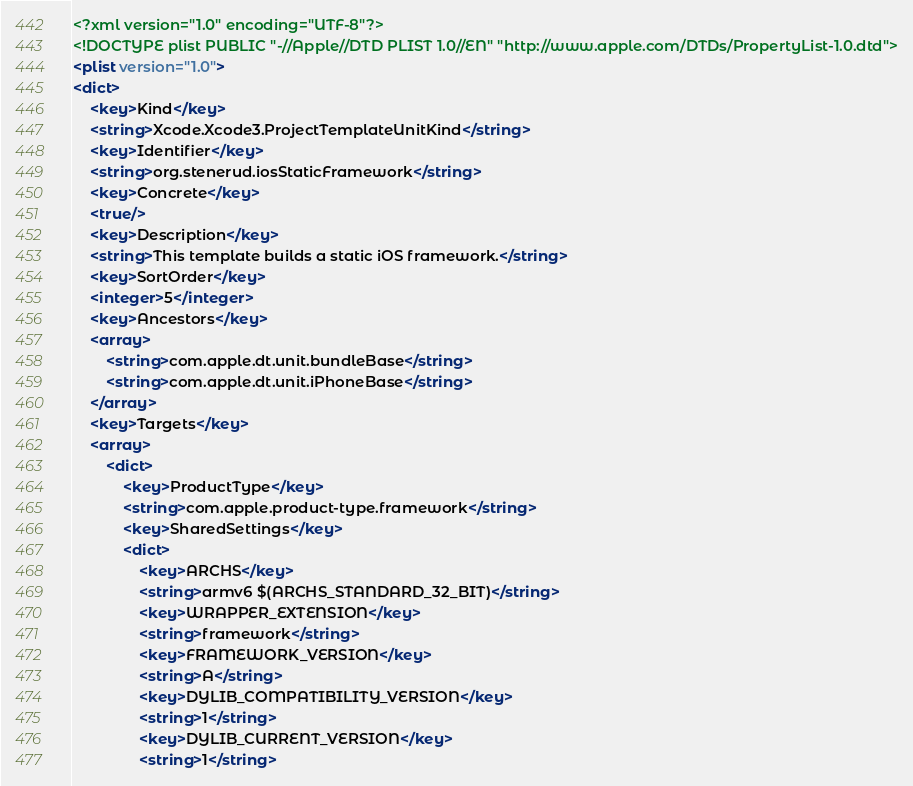<code> <loc_0><loc_0><loc_500><loc_500><_XML_><?xml version="1.0" encoding="UTF-8"?>
<!DOCTYPE plist PUBLIC "-//Apple//DTD PLIST 1.0//EN" "http://www.apple.com/DTDs/PropertyList-1.0.dtd">
<plist version="1.0">
<dict>
	<key>Kind</key>
	<string>Xcode.Xcode3.ProjectTemplateUnitKind</string>
	<key>Identifier</key>
	<string>org.stenerud.iosStaticFramework</string>
	<key>Concrete</key>
	<true/>
	<key>Description</key>
	<string>This template builds a static iOS framework.</string>
	<key>SortOrder</key>
	<integer>5</integer>
	<key>Ancestors</key>
	<array>
		<string>com.apple.dt.unit.bundleBase</string>
		<string>com.apple.dt.unit.iPhoneBase</string>
	</array>
	<key>Targets</key>
	<array>
		<dict>
			<key>ProductType</key>
			<string>com.apple.product-type.framework</string>
			<key>SharedSettings</key>
			<dict>
				<key>ARCHS</key>
				<string>armv6 $(ARCHS_STANDARD_32_BIT)</string>
				<key>WRAPPER_EXTENSION</key>
				<string>framework</string>
				<key>FRAMEWORK_VERSION</key>
				<string>A</string>
				<key>DYLIB_COMPATIBILITY_VERSION</key>
				<string>1</string>
				<key>DYLIB_CURRENT_VERSION</key>
				<string>1</string></code> 